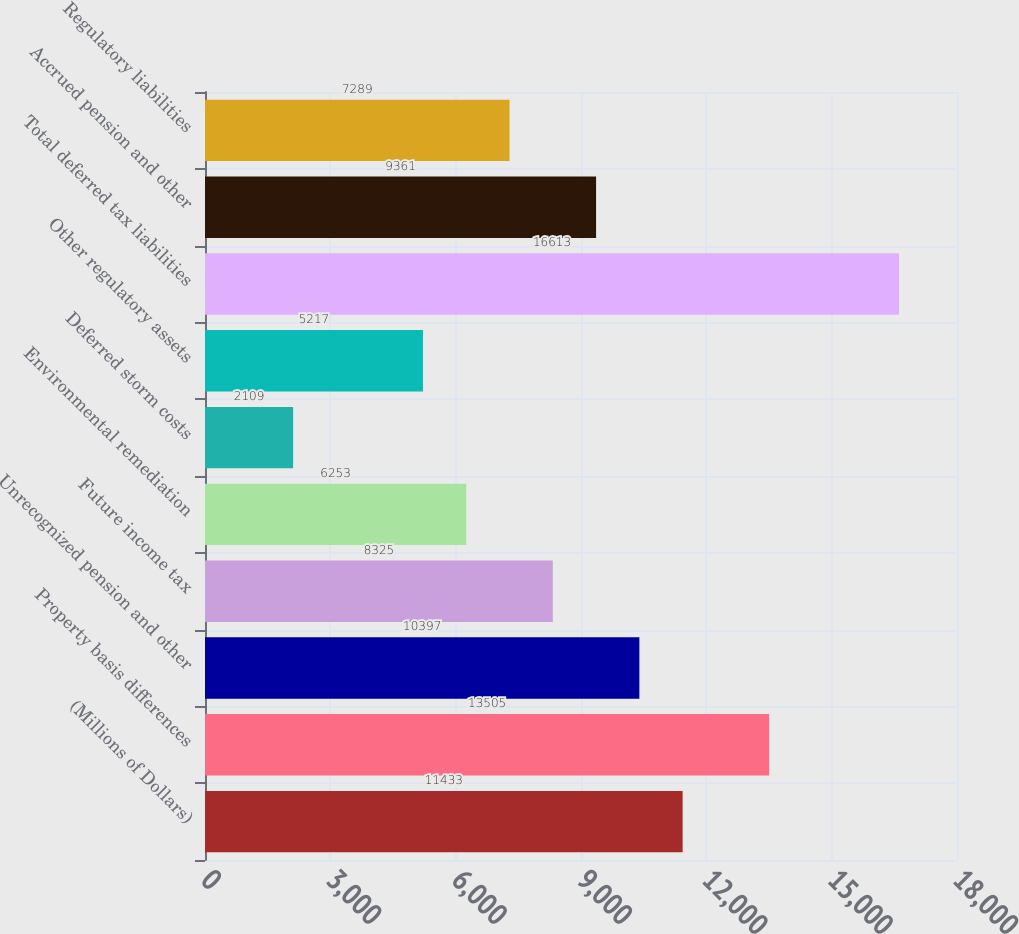Convert chart. <chart><loc_0><loc_0><loc_500><loc_500><bar_chart><fcel>(Millions of Dollars)<fcel>Property basis differences<fcel>Unrecognized pension and other<fcel>Future income tax<fcel>Environmental remediation<fcel>Deferred storm costs<fcel>Other regulatory assets<fcel>Total deferred tax liabilities<fcel>Accrued pension and other<fcel>Regulatory liabilities<nl><fcel>11433<fcel>13505<fcel>10397<fcel>8325<fcel>6253<fcel>2109<fcel>5217<fcel>16613<fcel>9361<fcel>7289<nl></chart> 